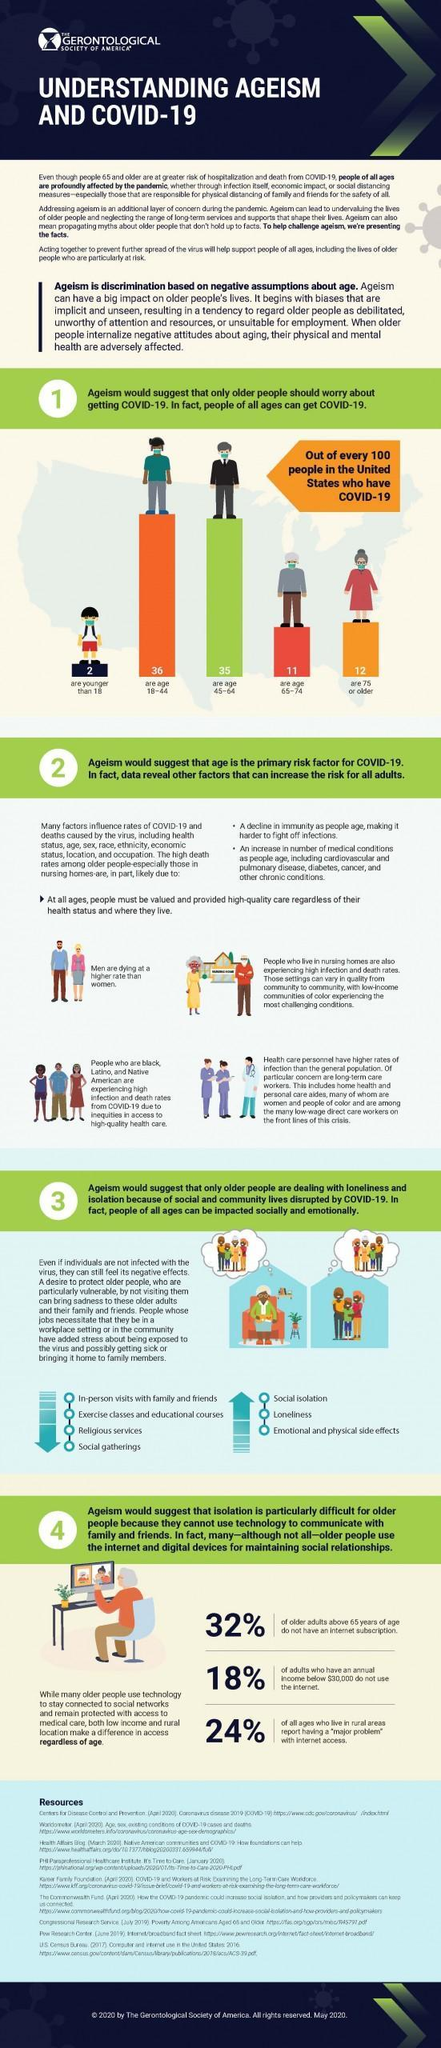What percentage of adults above 65 years of age have an internet subscription?
Answer the question with a short phrase. 68% Which age group has the lowest number of Covid-19 in the United States? younger than 18 Which age group has the highest number of Covid-19 in the United States? 18-44 